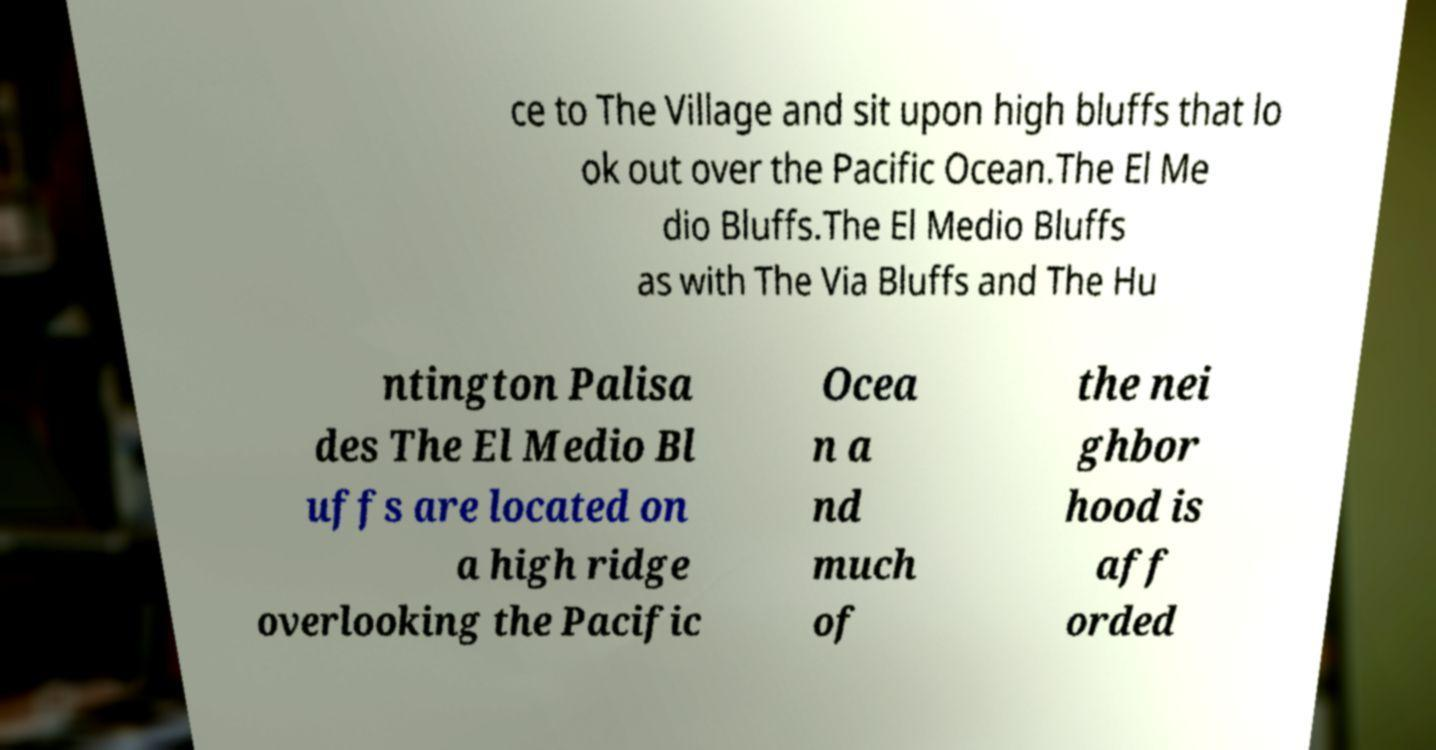Could you assist in decoding the text presented in this image and type it out clearly? ce to The Village and sit upon high bluffs that lo ok out over the Pacific Ocean.The El Me dio Bluffs.The El Medio Bluffs as with The Via Bluffs and The Hu ntington Palisa des The El Medio Bl uffs are located on a high ridge overlooking the Pacific Ocea n a nd much of the nei ghbor hood is aff orded 